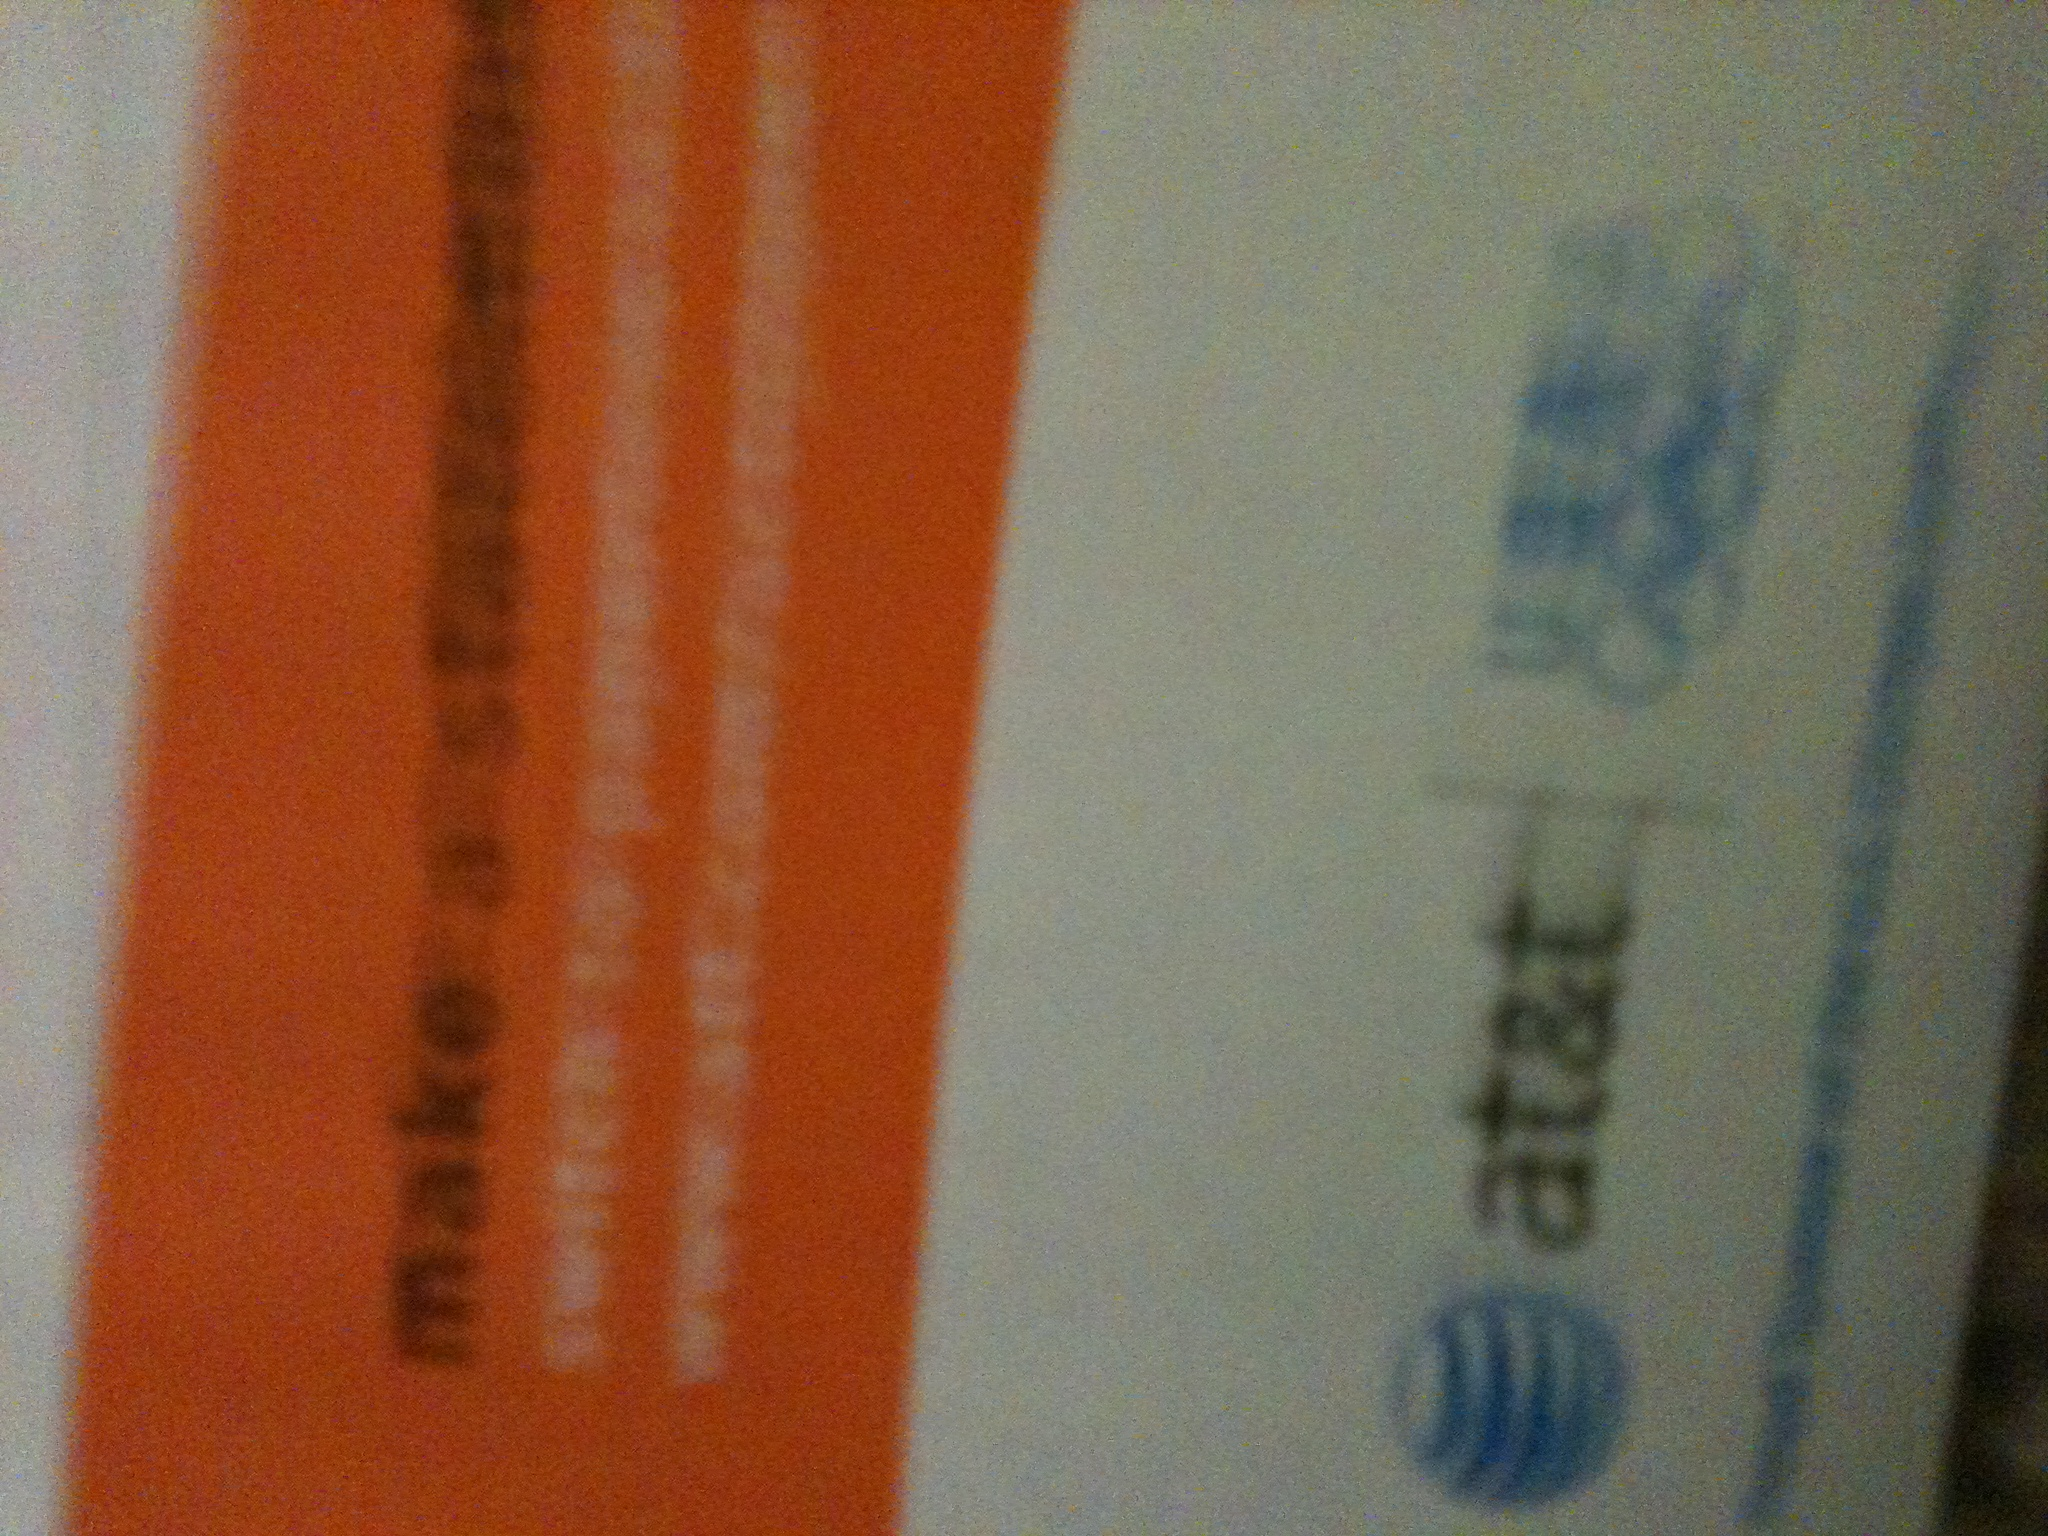Where might such advertisements be commonly distributed? Advertisements like this one are typically mailed directly to homes or businesses. They might also be included in billing statements from AT&T or distributed in stores. 